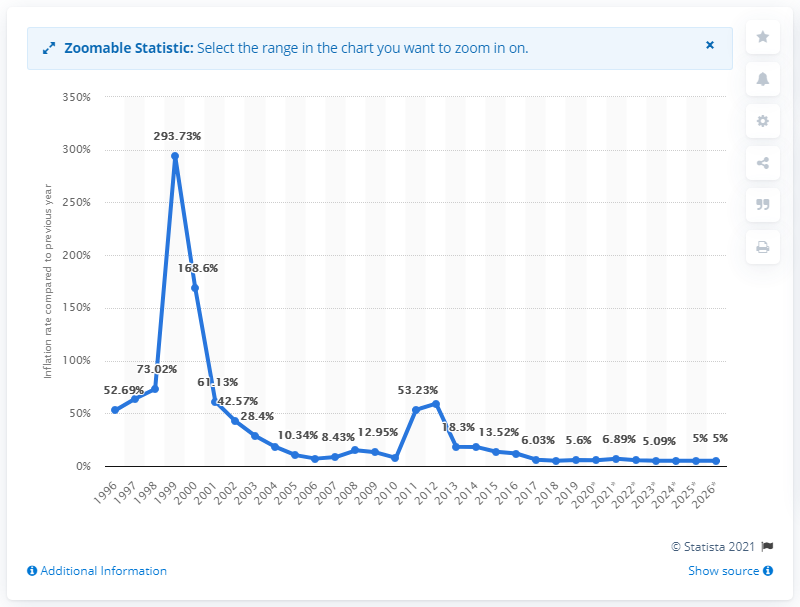Point out several critical features in this image. In 2019, the inflation rate in Belarus was 5.6%. 